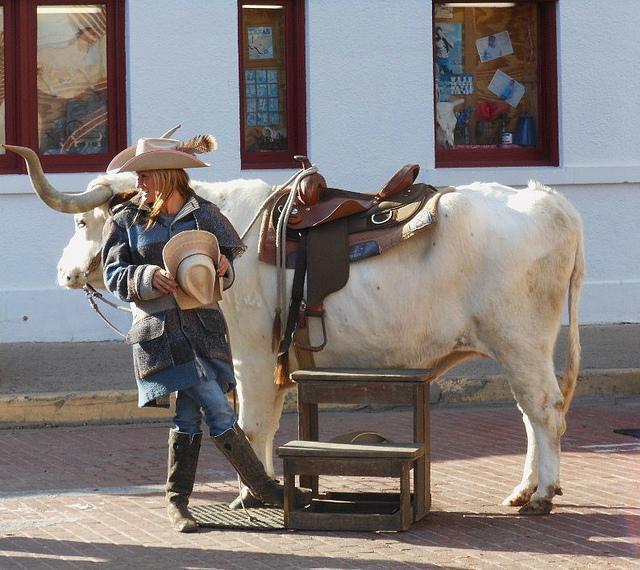Is the caption "The cow is behind the person." a true representation of the image?
Answer yes or no. Yes. Does the caption "The person is on top of the cow." correctly depict the image?
Answer yes or no. No. 